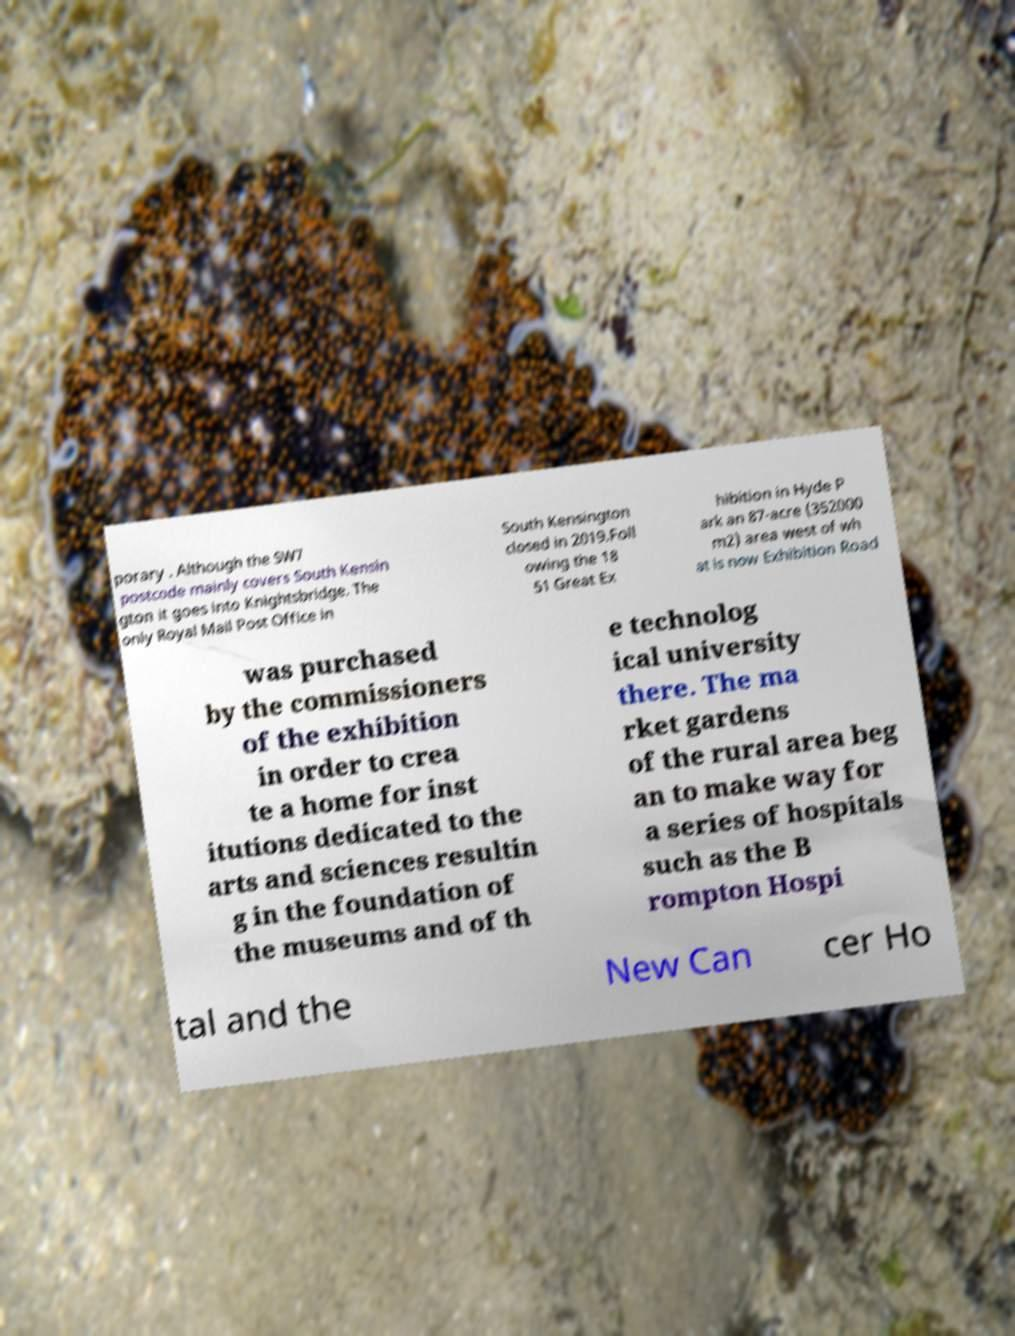Could you extract and type out the text from this image? porary . Although the SW7 postcode mainly covers South Kensin gton it goes into Knightsbridge. The only Royal Mail Post Office in South Kensington closed in 2019.Foll owing the 18 51 Great Ex hibition in Hyde P ark an 87-acre (352000 m2) area west of wh at is now Exhibition Road was purchased by the commissioners of the exhibition in order to crea te a home for inst itutions dedicated to the arts and sciences resultin g in the foundation of the museums and of th e technolog ical university there. The ma rket gardens of the rural area beg an to make way for a series of hospitals such as the B rompton Hospi tal and the New Can cer Ho 